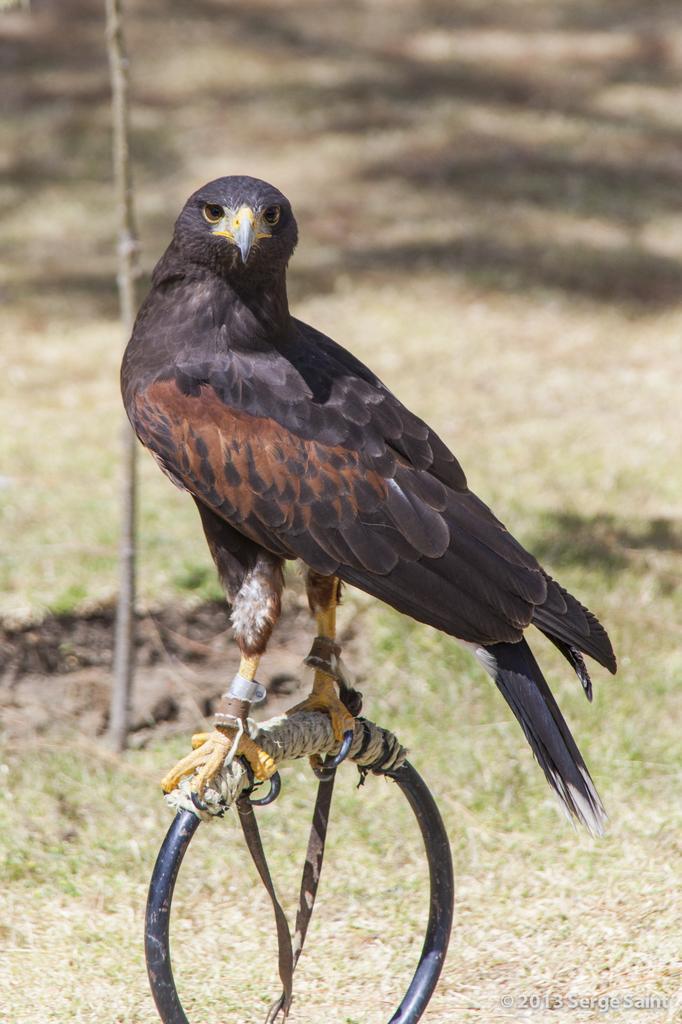In one or two sentences, can you explain what this image depicts? In this image there is a bird standing on the ring. On the ring there is a thread. At the bottom there is ground. In the background there is a stick. 